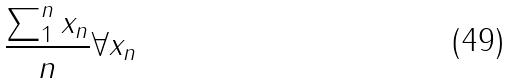<formula> <loc_0><loc_0><loc_500><loc_500>\frac { \sum _ { 1 } ^ { n } x _ { n } } { n } \forall x _ { n }</formula> 